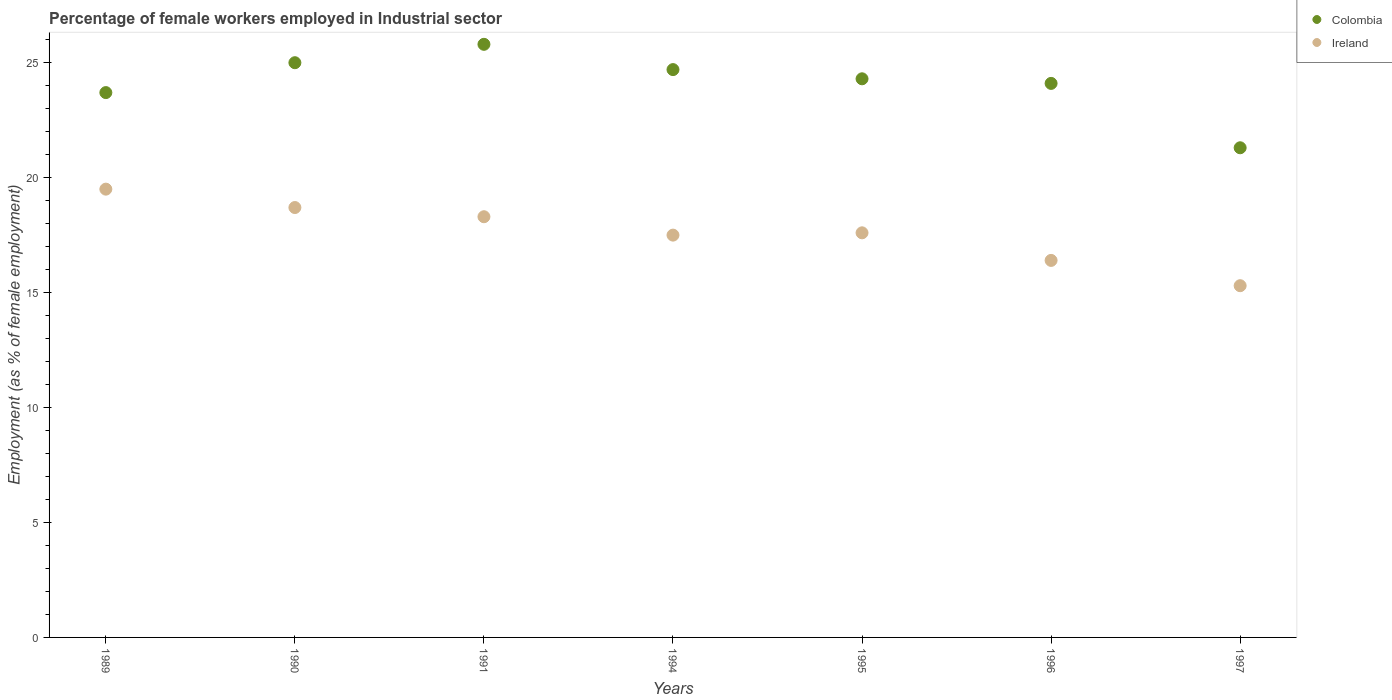How many different coloured dotlines are there?
Make the answer very short. 2. What is the percentage of females employed in Industrial sector in Colombia in 1996?
Ensure brevity in your answer.  24.1. Across all years, what is the maximum percentage of females employed in Industrial sector in Colombia?
Your response must be concise. 25.8. Across all years, what is the minimum percentage of females employed in Industrial sector in Ireland?
Your response must be concise. 15.3. What is the total percentage of females employed in Industrial sector in Colombia in the graph?
Make the answer very short. 168.9. What is the difference between the percentage of females employed in Industrial sector in Ireland in 1994 and that in 1996?
Give a very brief answer. 1.1. What is the difference between the percentage of females employed in Industrial sector in Colombia in 1989 and the percentage of females employed in Industrial sector in Ireland in 1996?
Offer a very short reply. 7.3. What is the average percentage of females employed in Industrial sector in Ireland per year?
Offer a terse response. 17.61. In the year 1996, what is the difference between the percentage of females employed in Industrial sector in Colombia and percentage of females employed in Industrial sector in Ireland?
Provide a succinct answer. 7.7. In how many years, is the percentage of females employed in Industrial sector in Colombia greater than 25 %?
Give a very brief answer. 1. What is the ratio of the percentage of females employed in Industrial sector in Colombia in 1990 to that in 1996?
Ensure brevity in your answer.  1.04. What is the difference between the highest and the second highest percentage of females employed in Industrial sector in Ireland?
Offer a very short reply. 0.8. What is the difference between the highest and the lowest percentage of females employed in Industrial sector in Ireland?
Make the answer very short. 4.2. In how many years, is the percentage of females employed in Industrial sector in Colombia greater than the average percentage of females employed in Industrial sector in Colombia taken over all years?
Offer a very short reply. 4. Is the sum of the percentage of females employed in Industrial sector in Ireland in 1991 and 1995 greater than the maximum percentage of females employed in Industrial sector in Colombia across all years?
Make the answer very short. Yes. Is the percentage of females employed in Industrial sector in Colombia strictly greater than the percentage of females employed in Industrial sector in Ireland over the years?
Offer a terse response. Yes. What is the difference between two consecutive major ticks on the Y-axis?
Offer a very short reply. 5. Does the graph contain any zero values?
Offer a terse response. No. Does the graph contain grids?
Offer a terse response. No. How many legend labels are there?
Provide a succinct answer. 2. What is the title of the graph?
Make the answer very short. Percentage of female workers employed in Industrial sector. What is the label or title of the X-axis?
Offer a terse response. Years. What is the label or title of the Y-axis?
Provide a succinct answer. Employment (as % of female employment). What is the Employment (as % of female employment) in Colombia in 1989?
Your answer should be compact. 23.7. What is the Employment (as % of female employment) in Ireland in 1989?
Make the answer very short. 19.5. What is the Employment (as % of female employment) of Colombia in 1990?
Your answer should be compact. 25. What is the Employment (as % of female employment) of Ireland in 1990?
Provide a succinct answer. 18.7. What is the Employment (as % of female employment) in Colombia in 1991?
Your answer should be very brief. 25.8. What is the Employment (as % of female employment) of Ireland in 1991?
Give a very brief answer. 18.3. What is the Employment (as % of female employment) of Colombia in 1994?
Your answer should be compact. 24.7. What is the Employment (as % of female employment) in Colombia in 1995?
Offer a very short reply. 24.3. What is the Employment (as % of female employment) in Ireland in 1995?
Provide a short and direct response. 17.6. What is the Employment (as % of female employment) of Colombia in 1996?
Your answer should be very brief. 24.1. What is the Employment (as % of female employment) of Ireland in 1996?
Keep it short and to the point. 16.4. What is the Employment (as % of female employment) in Colombia in 1997?
Give a very brief answer. 21.3. What is the Employment (as % of female employment) of Ireland in 1997?
Provide a short and direct response. 15.3. Across all years, what is the maximum Employment (as % of female employment) in Colombia?
Make the answer very short. 25.8. Across all years, what is the minimum Employment (as % of female employment) of Colombia?
Your answer should be very brief. 21.3. Across all years, what is the minimum Employment (as % of female employment) of Ireland?
Your answer should be compact. 15.3. What is the total Employment (as % of female employment) in Colombia in the graph?
Keep it short and to the point. 168.9. What is the total Employment (as % of female employment) in Ireland in the graph?
Your response must be concise. 123.3. What is the difference between the Employment (as % of female employment) of Colombia in 1989 and that in 1990?
Your answer should be very brief. -1.3. What is the difference between the Employment (as % of female employment) of Colombia in 1989 and that in 1991?
Ensure brevity in your answer.  -2.1. What is the difference between the Employment (as % of female employment) in Colombia in 1989 and that in 1994?
Make the answer very short. -1. What is the difference between the Employment (as % of female employment) in Ireland in 1989 and that in 1994?
Your response must be concise. 2. What is the difference between the Employment (as % of female employment) in Ireland in 1989 and that in 1995?
Your answer should be compact. 1.9. What is the difference between the Employment (as % of female employment) of Colombia in 1989 and that in 1996?
Ensure brevity in your answer.  -0.4. What is the difference between the Employment (as % of female employment) of Colombia in 1989 and that in 1997?
Your answer should be compact. 2.4. What is the difference between the Employment (as % of female employment) of Ireland in 1989 and that in 1997?
Your response must be concise. 4.2. What is the difference between the Employment (as % of female employment) in Colombia in 1990 and that in 1994?
Offer a terse response. 0.3. What is the difference between the Employment (as % of female employment) of Colombia in 1990 and that in 1995?
Make the answer very short. 0.7. What is the difference between the Employment (as % of female employment) of Ireland in 1990 and that in 1996?
Give a very brief answer. 2.3. What is the difference between the Employment (as % of female employment) in Colombia in 1990 and that in 1997?
Offer a very short reply. 3.7. What is the difference between the Employment (as % of female employment) of Ireland in 1990 and that in 1997?
Ensure brevity in your answer.  3.4. What is the difference between the Employment (as % of female employment) in Ireland in 1991 and that in 1995?
Your answer should be very brief. 0.7. What is the difference between the Employment (as % of female employment) in Colombia in 1991 and that in 1996?
Keep it short and to the point. 1.7. What is the difference between the Employment (as % of female employment) in Colombia in 1991 and that in 1997?
Your response must be concise. 4.5. What is the difference between the Employment (as % of female employment) of Colombia in 1994 and that in 1995?
Keep it short and to the point. 0.4. What is the difference between the Employment (as % of female employment) of Colombia in 1994 and that in 1996?
Keep it short and to the point. 0.6. What is the difference between the Employment (as % of female employment) in Ireland in 1994 and that in 1996?
Provide a short and direct response. 1.1. What is the difference between the Employment (as % of female employment) of Colombia in 1994 and that in 1997?
Offer a terse response. 3.4. What is the difference between the Employment (as % of female employment) of Colombia in 1996 and that in 1997?
Your answer should be compact. 2.8. What is the difference between the Employment (as % of female employment) in Ireland in 1996 and that in 1997?
Offer a terse response. 1.1. What is the difference between the Employment (as % of female employment) in Colombia in 1989 and the Employment (as % of female employment) in Ireland in 1996?
Make the answer very short. 7.3. What is the difference between the Employment (as % of female employment) of Colombia in 1990 and the Employment (as % of female employment) of Ireland in 1995?
Provide a succinct answer. 7.4. What is the difference between the Employment (as % of female employment) of Colombia in 1990 and the Employment (as % of female employment) of Ireland in 1997?
Ensure brevity in your answer.  9.7. What is the difference between the Employment (as % of female employment) of Colombia in 1991 and the Employment (as % of female employment) of Ireland in 1996?
Your response must be concise. 9.4. What is the difference between the Employment (as % of female employment) in Colombia in 1995 and the Employment (as % of female employment) in Ireland in 1996?
Your answer should be very brief. 7.9. What is the difference between the Employment (as % of female employment) of Colombia in 1996 and the Employment (as % of female employment) of Ireland in 1997?
Offer a terse response. 8.8. What is the average Employment (as % of female employment) of Colombia per year?
Offer a very short reply. 24.13. What is the average Employment (as % of female employment) in Ireland per year?
Provide a succinct answer. 17.61. In the year 1990, what is the difference between the Employment (as % of female employment) in Colombia and Employment (as % of female employment) in Ireland?
Provide a short and direct response. 6.3. In the year 1991, what is the difference between the Employment (as % of female employment) in Colombia and Employment (as % of female employment) in Ireland?
Keep it short and to the point. 7.5. In the year 1994, what is the difference between the Employment (as % of female employment) of Colombia and Employment (as % of female employment) of Ireland?
Your answer should be very brief. 7.2. In the year 1995, what is the difference between the Employment (as % of female employment) in Colombia and Employment (as % of female employment) in Ireland?
Provide a succinct answer. 6.7. In the year 1996, what is the difference between the Employment (as % of female employment) of Colombia and Employment (as % of female employment) of Ireland?
Give a very brief answer. 7.7. What is the ratio of the Employment (as % of female employment) in Colombia in 1989 to that in 1990?
Provide a short and direct response. 0.95. What is the ratio of the Employment (as % of female employment) of Ireland in 1989 to that in 1990?
Offer a terse response. 1.04. What is the ratio of the Employment (as % of female employment) of Colombia in 1989 to that in 1991?
Your answer should be compact. 0.92. What is the ratio of the Employment (as % of female employment) in Ireland in 1989 to that in 1991?
Your answer should be very brief. 1.07. What is the ratio of the Employment (as % of female employment) in Colombia in 1989 to that in 1994?
Offer a very short reply. 0.96. What is the ratio of the Employment (as % of female employment) of Ireland in 1989 to that in 1994?
Offer a terse response. 1.11. What is the ratio of the Employment (as % of female employment) in Colombia in 1989 to that in 1995?
Ensure brevity in your answer.  0.98. What is the ratio of the Employment (as % of female employment) in Ireland in 1989 to that in 1995?
Offer a very short reply. 1.11. What is the ratio of the Employment (as % of female employment) of Colombia in 1989 to that in 1996?
Make the answer very short. 0.98. What is the ratio of the Employment (as % of female employment) in Ireland in 1989 to that in 1996?
Provide a short and direct response. 1.19. What is the ratio of the Employment (as % of female employment) of Colombia in 1989 to that in 1997?
Your response must be concise. 1.11. What is the ratio of the Employment (as % of female employment) of Ireland in 1989 to that in 1997?
Your answer should be very brief. 1.27. What is the ratio of the Employment (as % of female employment) in Colombia in 1990 to that in 1991?
Provide a succinct answer. 0.97. What is the ratio of the Employment (as % of female employment) in Ireland in 1990 to that in 1991?
Your response must be concise. 1.02. What is the ratio of the Employment (as % of female employment) in Colombia in 1990 to that in 1994?
Provide a succinct answer. 1.01. What is the ratio of the Employment (as % of female employment) of Ireland in 1990 to that in 1994?
Give a very brief answer. 1.07. What is the ratio of the Employment (as % of female employment) in Colombia in 1990 to that in 1995?
Your answer should be compact. 1.03. What is the ratio of the Employment (as % of female employment) in Colombia in 1990 to that in 1996?
Offer a terse response. 1.04. What is the ratio of the Employment (as % of female employment) of Ireland in 1990 to that in 1996?
Ensure brevity in your answer.  1.14. What is the ratio of the Employment (as % of female employment) in Colombia in 1990 to that in 1997?
Offer a very short reply. 1.17. What is the ratio of the Employment (as % of female employment) of Ireland in 1990 to that in 1997?
Offer a very short reply. 1.22. What is the ratio of the Employment (as % of female employment) of Colombia in 1991 to that in 1994?
Provide a succinct answer. 1.04. What is the ratio of the Employment (as % of female employment) of Ireland in 1991 to that in 1994?
Give a very brief answer. 1.05. What is the ratio of the Employment (as % of female employment) in Colombia in 1991 to that in 1995?
Ensure brevity in your answer.  1.06. What is the ratio of the Employment (as % of female employment) in Ireland in 1991 to that in 1995?
Make the answer very short. 1.04. What is the ratio of the Employment (as % of female employment) in Colombia in 1991 to that in 1996?
Your answer should be very brief. 1.07. What is the ratio of the Employment (as % of female employment) of Ireland in 1991 to that in 1996?
Your answer should be compact. 1.12. What is the ratio of the Employment (as % of female employment) in Colombia in 1991 to that in 1997?
Your response must be concise. 1.21. What is the ratio of the Employment (as % of female employment) of Ireland in 1991 to that in 1997?
Ensure brevity in your answer.  1.2. What is the ratio of the Employment (as % of female employment) of Colombia in 1994 to that in 1995?
Keep it short and to the point. 1.02. What is the ratio of the Employment (as % of female employment) of Colombia in 1994 to that in 1996?
Provide a succinct answer. 1.02. What is the ratio of the Employment (as % of female employment) of Ireland in 1994 to that in 1996?
Keep it short and to the point. 1.07. What is the ratio of the Employment (as % of female employment) of Colombia in 1994 to that in 1997?
Keep it short and to the point. 1.16. What is the ratio of the Employment (as % of female employment) in Ireland in 1994 to that in 1997?
Your response must be concise. 1.14. What is the ratio of the Employment (as % of female employment) of Colombia in 1995 to that in 1996?
Your answer should be very brief. 1.01. What is the ratio of the Employment (as % of female employment) in Ireland in 1995 to that in 1996?
Make the answer very short. 1.07. What is the ratio of the Employment (as % of female employment) of Colombia in 1995 to that in 1997?
Provide a short and direct response. 1.14. What is the ratio of the Employment (as % of female employment) of Ireland in 1995 to that in 1997?
Offer a very short reply. 1.15. What is the ratio of the Employment (as % of female employment) in Colombia in 1996 to that in 1997?
Your answer should be compact. 1.13. What is the ratio of the Employment (as % of female employment) of Ireland in 1996 to that in 1997?
Ensure brevity in your answer.  1.07. What is the difference between the highest and the second highest Employment (as % of female employment) in Colombia?
Provide a short and direct response. 0.8. 